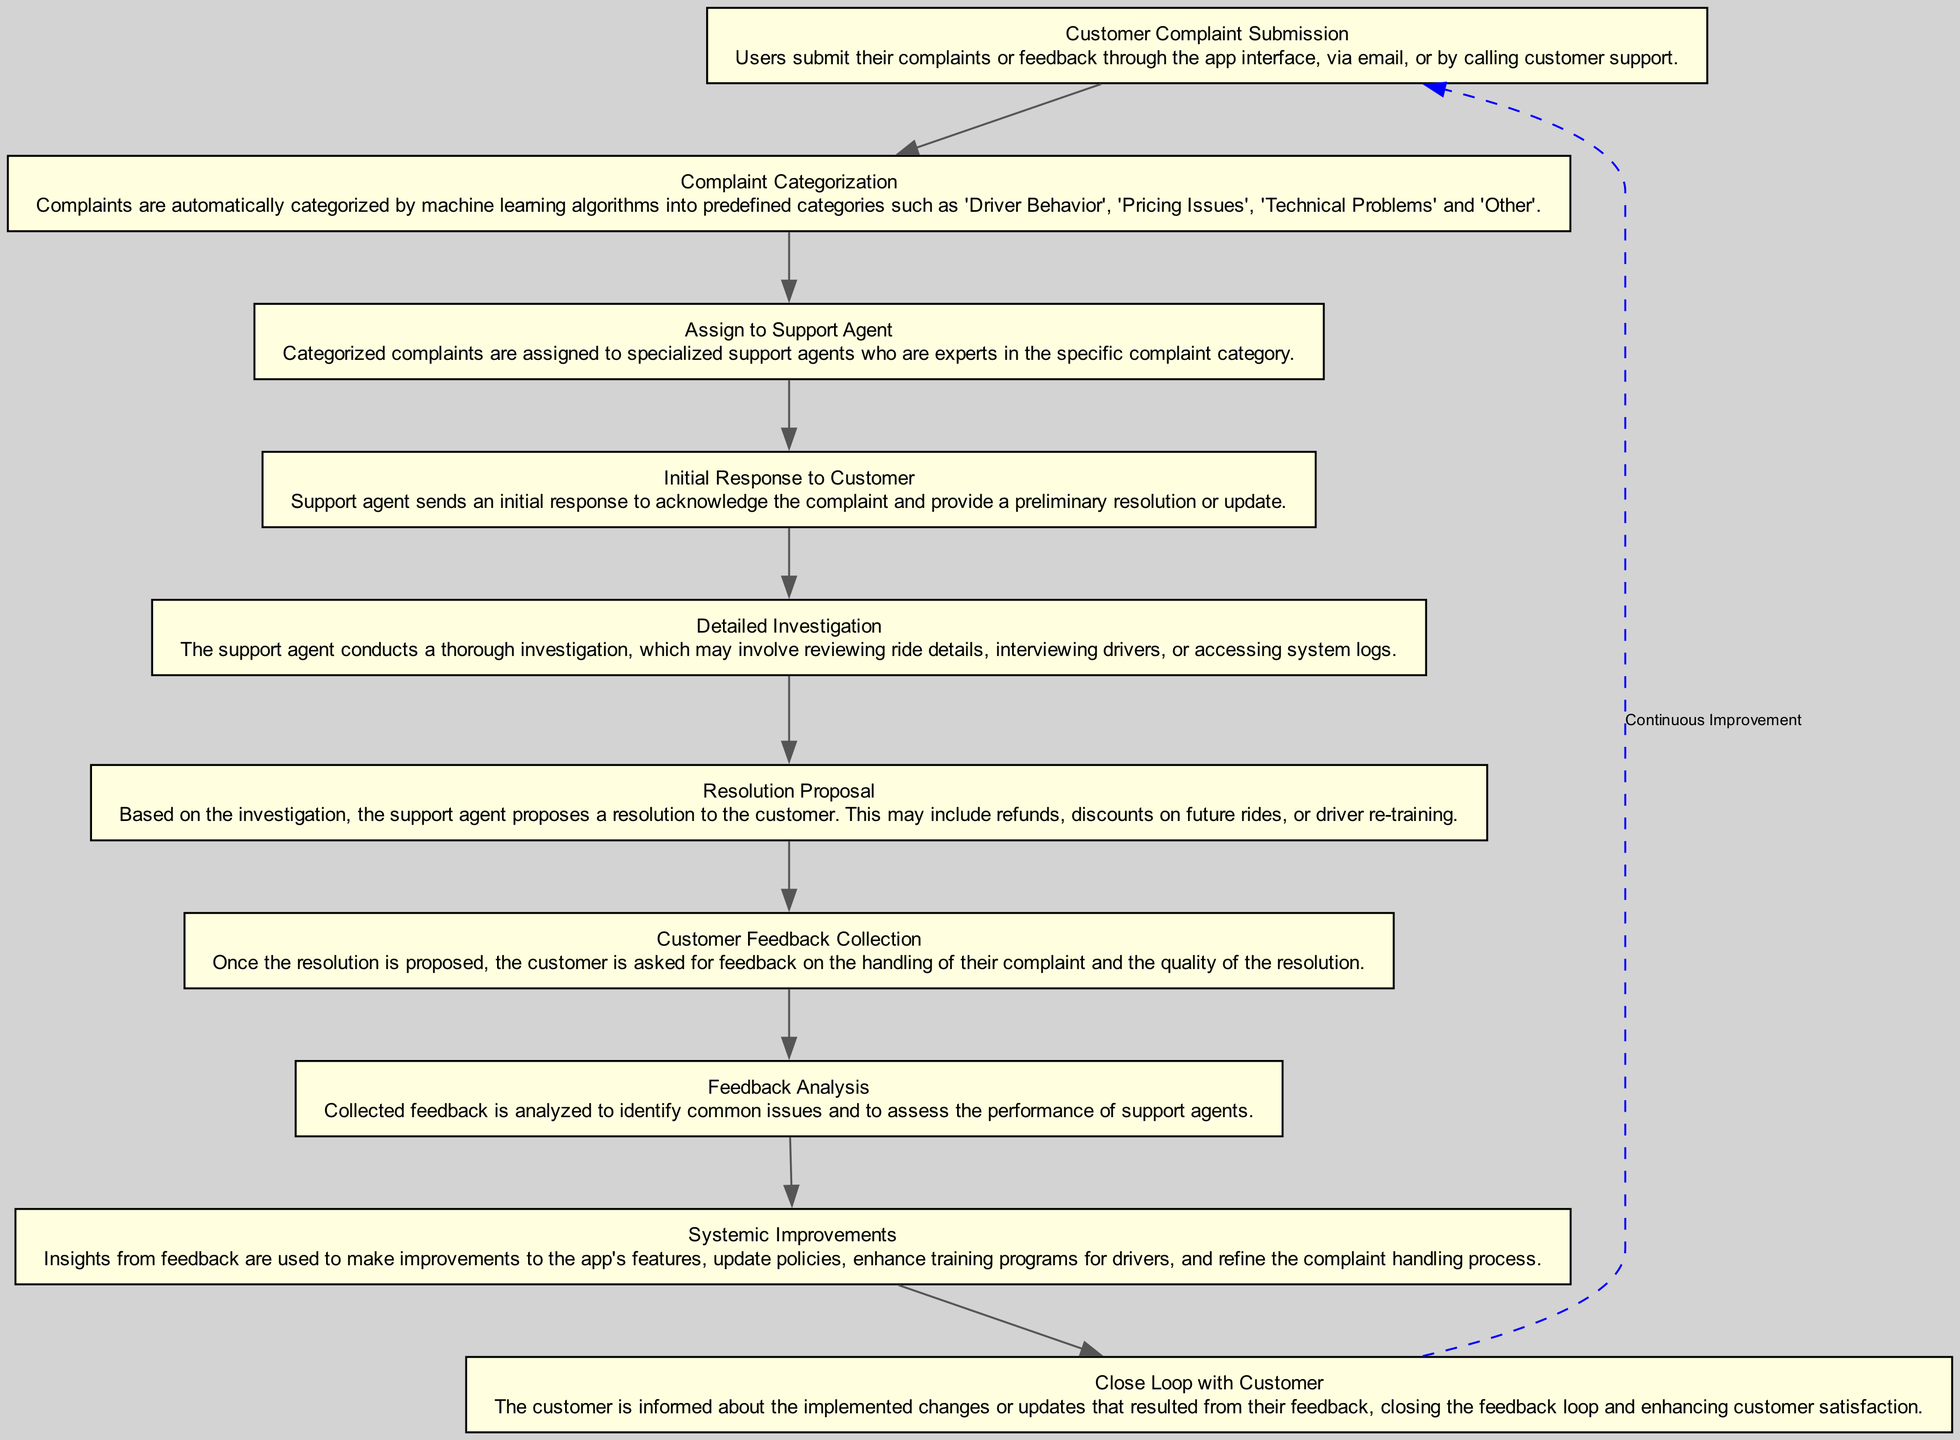What's the first step in the feedback loop? The first step, as indicated in the diagram, is "Customer Complaint Submission" where users submit their complaints or feedback through various channels.
Answer: Customer Complaint Submission What is the last step of the process? The last step depicted in the diagram is "Close Loop with Customer", where customers are informed about changes or updates resulting from their feedback, thus closing the feedback loop.
Answer: Close Loop with Customer How many nodes are there in the diagram? Counting all the unique steps in the flow chart, there are 10 nodes that represent different stages in the customer support feedback loop process.
Answer: 10 Which step involves analyzing feedback? The step that involves analyzing feedback is "Feedback Analysis", where the collected feedback is assessed to identify common issues and evaluate support agent performance.
Answer: Feedback Analysis What action follows "Resolution Proposal"? After "Resolution Proposal", the subsequent action is "Customer Feedback Collection," where customers are asked for their feedback on the resolution provided by the support agent.
Answer: Customer Feedback Collection Which nodes are directly connected to the "Initial Response to Customer" node? The "Initial Response to Customer" node is directly connected both to the "Assign to Support Agent" node, as it follows the categorization, and to the "Detailed Investigation" node, as it leads to further investigation steps.
Answer: Assign to Support Agent, Detailed Investigation Explain the purpose of the "Systemic Improvements" node. The "Systemic Improvements" node utilizes insights gained from the "Feedback Analysis" step to implement enhancements to features, policies, training programs, and the complaint handling process, thereby aiming for continuous improvement based on feedback.
Answer: Improve functionalities Which node serves as the starting point for the feedback loop? The starting point of the feedback loop is defined by the "Customer Complaint Submission" node, which initiates the entire process of addressing customer complaints.
Answer: Customer Complaint Submission What does the dashed line indicate in the diagram? The dashed line from the last node back to the first node signifies a "Continuous Improvement" cycle, representing that the process aims to constantly revisit and refine the feedback loop using insights from previous complaints.
Answer: Continuous Improvement 